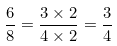Convert formula to latex. <formula><loc_0><loc_0><loc_500><loc_500>\frac { 6 } { 8 } = \frac { 3 \times 2 } { 4 \times 2 } = \frac { 3 } { 4 }</formula> 